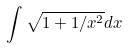<formula> <loc_0><loc_0><loc_500><loc_500>\int \sqrt { 1 + 1 / x ^ { 2 } } d x</formula> 